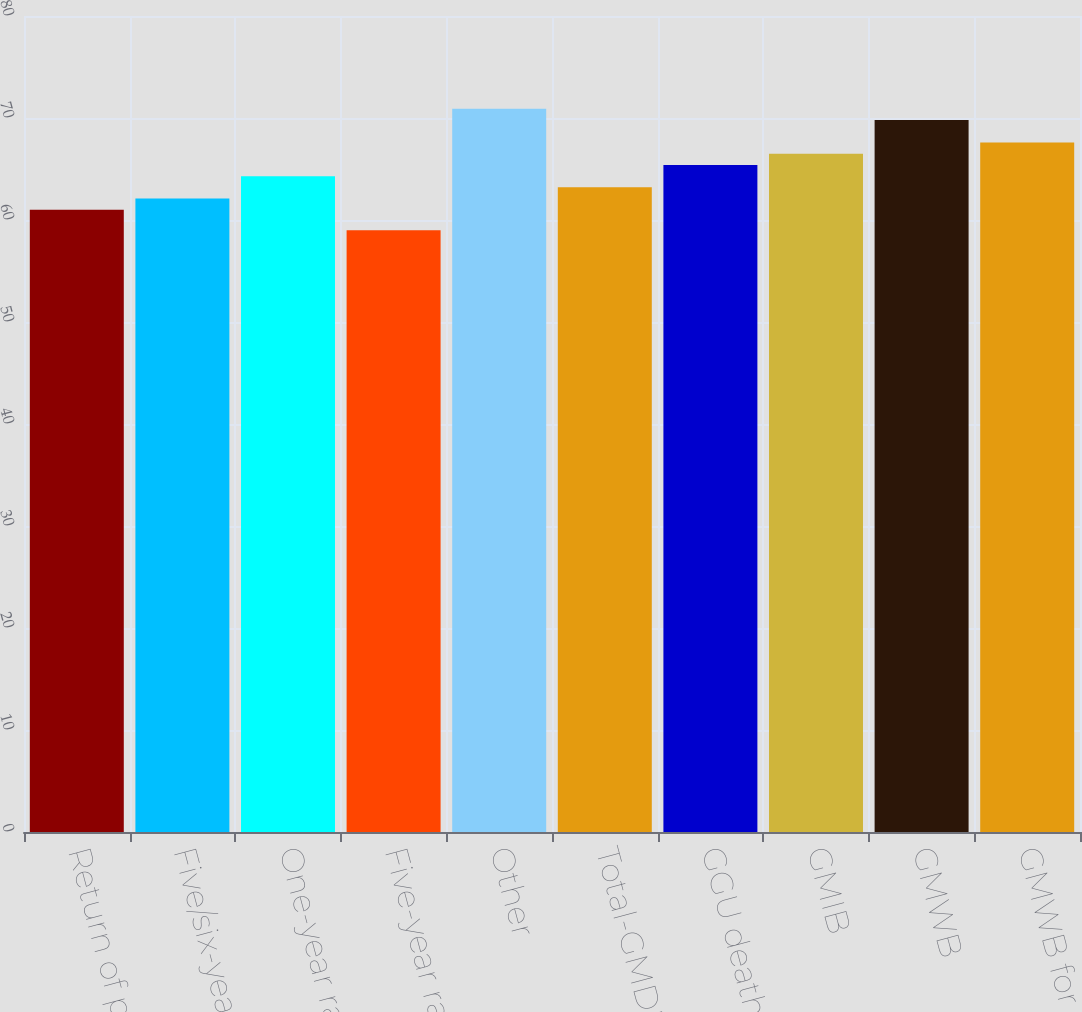Convert chart to OTSL. <chart><loc_0><loc_0><loc_500><loc_500><bar_chart><fcel>Return of premium<fcel>Five/six-year reset<fcel>One-year ratchet<fcel>Five-year ratchet<fcel>Other<fcel>Total-GMDB<fcel>GGU death benefit<fcel>GMIB<fcel>GMWB<fcel>GMWB for life<nl><fcel>61<fcel>62.1<fcel>64.3<fcel>59<fcel>70.9<fcel>63.2<fcel>65.4<fcel>66.5<fcel>69.8<fcel>67.6<nl></chart> 